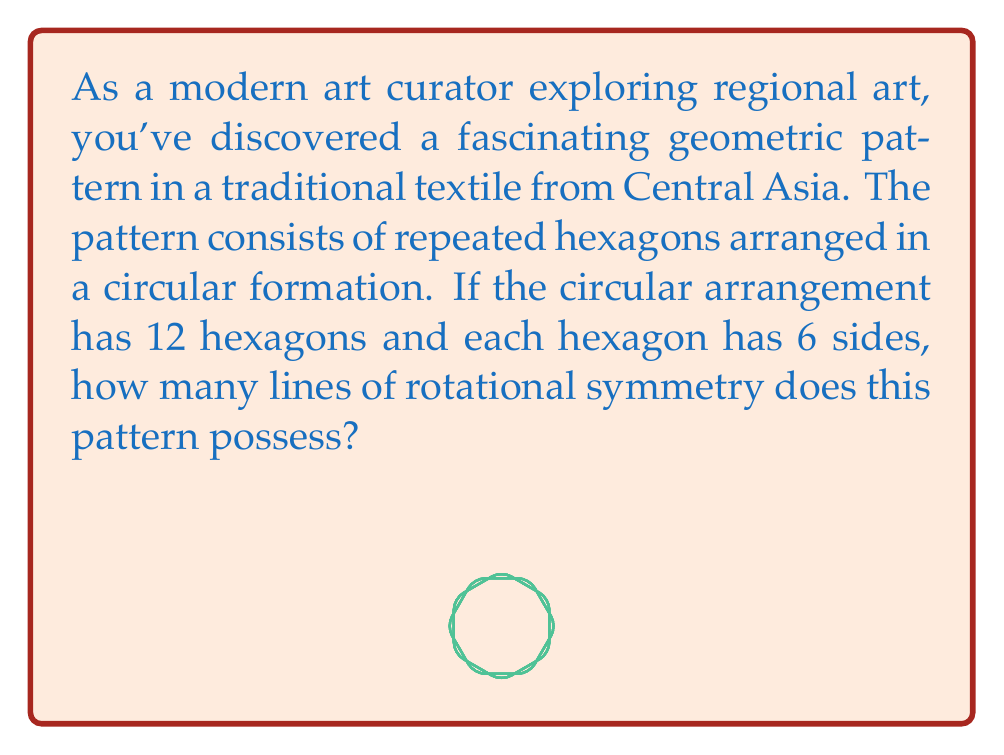Solve this math problem. To solve this problem, we need to understand the concept of rotational symmetry and how it applies to the given pattern:

1. Rotational symmetry occurs when an object can be rotated about its center by a certain angle and appear unchanged.

2. The number of lines of rotational symmetry is equal to the number of distinct rotations that bring the pattern back to its original position.

3. In this case, we have 12 hexagons arranged in a circle. This means we can rotate the entire pattern by multiples of $\frac{360°}{12} = 30°$ to bring it back to its original position.

4. To find the number of lines of rotational symmetry, we need to consider how many distinct 30° rotations we can make before the pattern repeats:

   $$\text{Number of rotations} = \frac{360°}{30°} = 12$$

5. However, we also need to consider if there are any additional symmetries due to the hexagons themselves. Each hexagon has 6-fold rotational symmetry (it can be rotated by multiples of 60° and look the same).

6. The greatest common divisor (GCD) of the circular arrangement's symmetry (12) and the hexagon's symmetry (6) will give us the total number of lines of rotational symmetry:

   $$GCD(12, 6) = 6$$

Therefore, the pattern has 6 lines of rotational symmetry.
Answer: The pattern has 6 lines of rotational symmetry. 